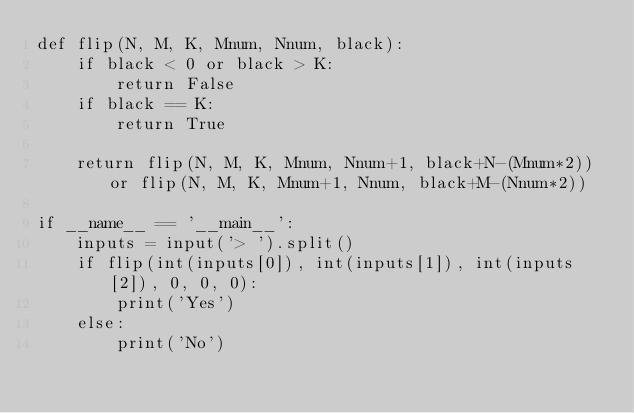Convert code to text. <code><loc_0><loc_0><loc_500><loc_500><_Python_>def flip(N, M, K, Mnum, Nnum, black):
    if black < 0 or black > K:
        return False
    if black == K:
        return True

    return flip(N, M, K, Mnum, Nnum+1, black+N-(Mnum*2)) or flip(N, M, K, Mnum+1, Nnum, black+M-(Nnum*2))

if __name__ == '__main__':
    inputs = input('> ').split()
    if flip(int(inputs[0]), int(inputs[1]), int(inputs[2]), 0, 0, 0):
        print('Yes')
    else:
        print('No')
</code> 